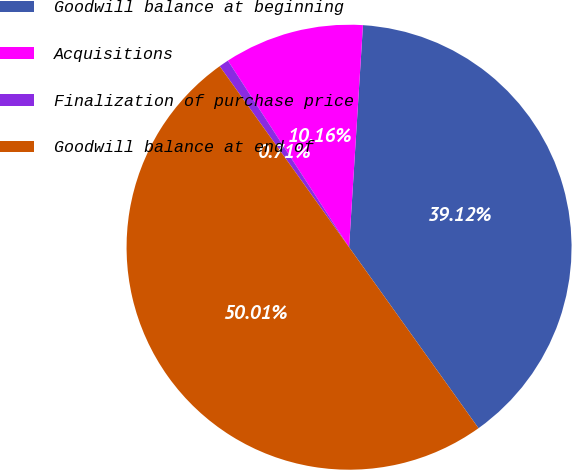Convert chart to OTSL. <chart><loc_0><loc_0><loc_500><loc_500><pie_chart><fcel>Goodwill balance at beginning<fcel>Acquisitions<fcel>Finalization of purchase price<fcel>Goodwill balance at end of<nl><fcel>39.12%<fcel>10.16%<fcel>0.71%<fcel>50.0%<nl></chart> 